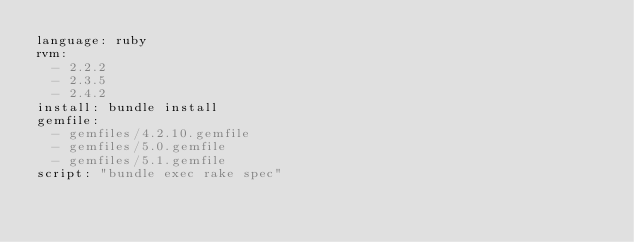<code> <loc_0><loc_0><loc_500><loc_500><_YAML_>language: ruby
rvm:
  - 2.2.2
  - 2.3.5
  - 2.4.2
install: bundle install
gemfile:
  - gemfiles/4.2.10.gemfile
  - gemfiles/5.0.gemfile
  - gemfiles/5.1.gemfile
script: "bundle exec rake spec"</code> 